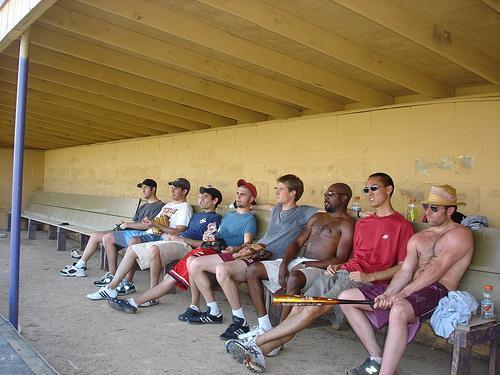How many men are wearing hats?
Give a very brief answer. 5. How many guys are wearing glasses?
Give a very brief answer. 3. How many benches can you see?
Give a very brief answer. 2. How many people can be seen?
Give a very brief answer. 3. 